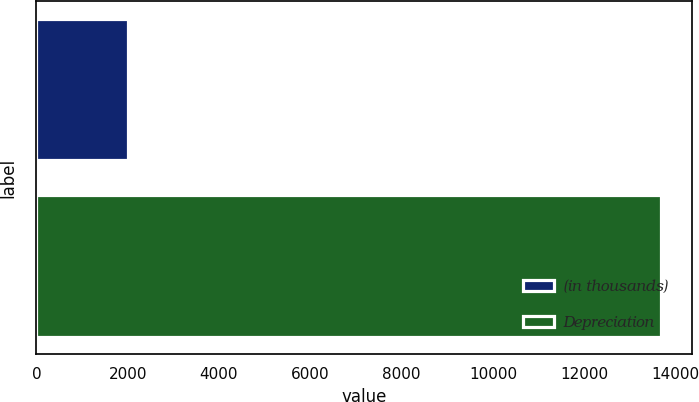<chart> <loc_0><loc_0><loc_500><loc_500><bar_chart><fcel>(in thousands)<fcel>Depreciation<nl><fcel>2007<fcel>13677<nl></chart> 